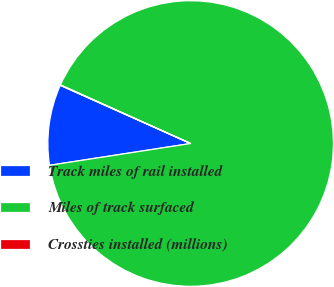Convert chart. <chart><loc_0><loc_0><loc_500><loc_500><pie_chart><fcel>Track miles of rail installed<fcel>Miles of track surfaced<fcel>Crossties installed (millions)<nl><fcel>9.12%<fcel>90.83%<fcel>0.05%<nl></chart> 